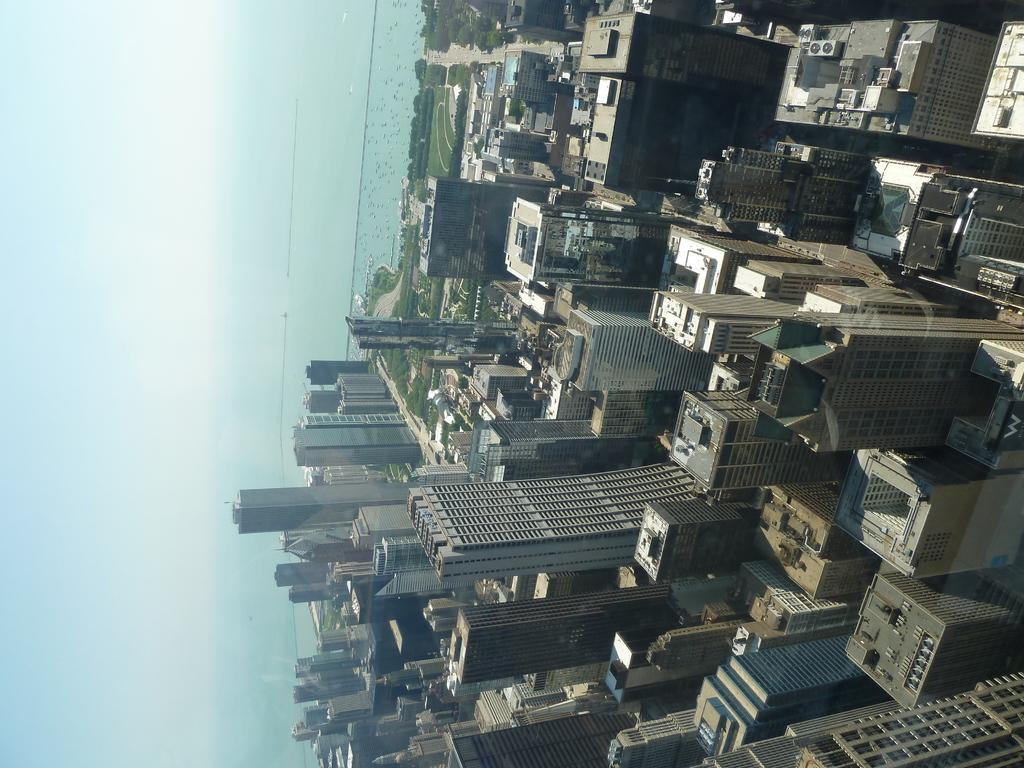What type of structures can be seen in the image? There are buildings in the image. What other natural elements are present in the image? There are trees and water visible in the image. What can be seen in the background of the image? The sky is visible in the background of the image. What type of invention is being demonstrated in the image? There is no invention being demonstrated in the image; it features buildings, trees, water, and the sky. How many flocks of birds can be seen in the image? There are no birds or flocks visible in the image. 